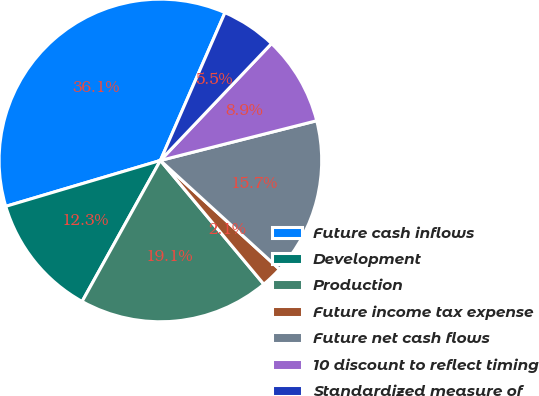Convert chart to OTSL. <chart><loc_0><loc_0><loc_500><loc_500><pie_chart><fcel>Future cash inflows<fcel>Development<fcel>Production<fcel>Future income tax expense<fcel>Future net cash flows<fcel>10 discount to reflect timing<fcel>Standardized measure of<nl><fcel>36.14%<fcel>12.34%<fcel>19.14%<fcel>2.14%<fcel>15.74%<fcel>8.94%<fcel>5.54%<nl></chart> 